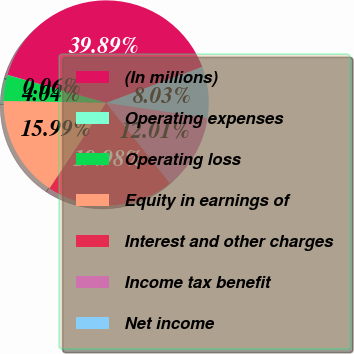Convert chart. <chart><loc_0><loc_0><loc_500><loc_500><pie_chart><fcel>(In millions)<fcel>Operating expenses<fcel>Operating loss<fcel>Equity in earnings of<fcel>Interest and other charges<fcel>Income tax benefit<fcel>Net income<nl><fcel>39.89%<fcel>0.06%<fcel>4.04%<fcel>15.99%<fcel>19.98%<fcel>12.01%<fcel>8.03%<nl></chart> 